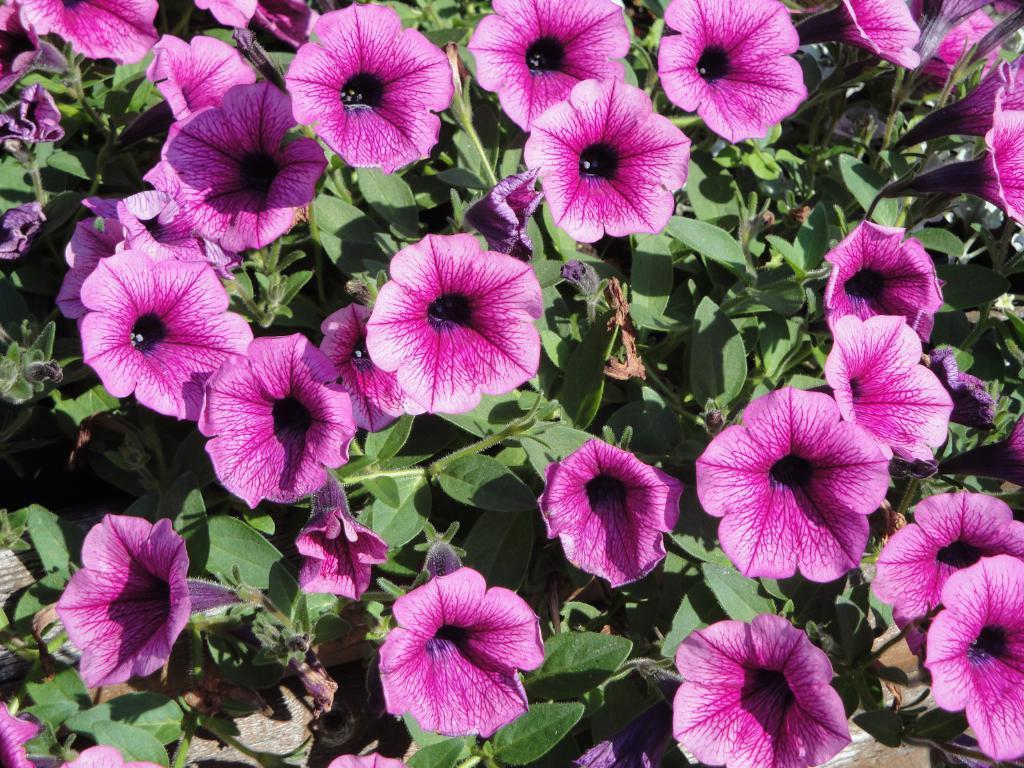How would you summarize this image in a sentence or two? in this picture, I can see a bunch of flowers which includes with leaves and stem also i can see a ground. 